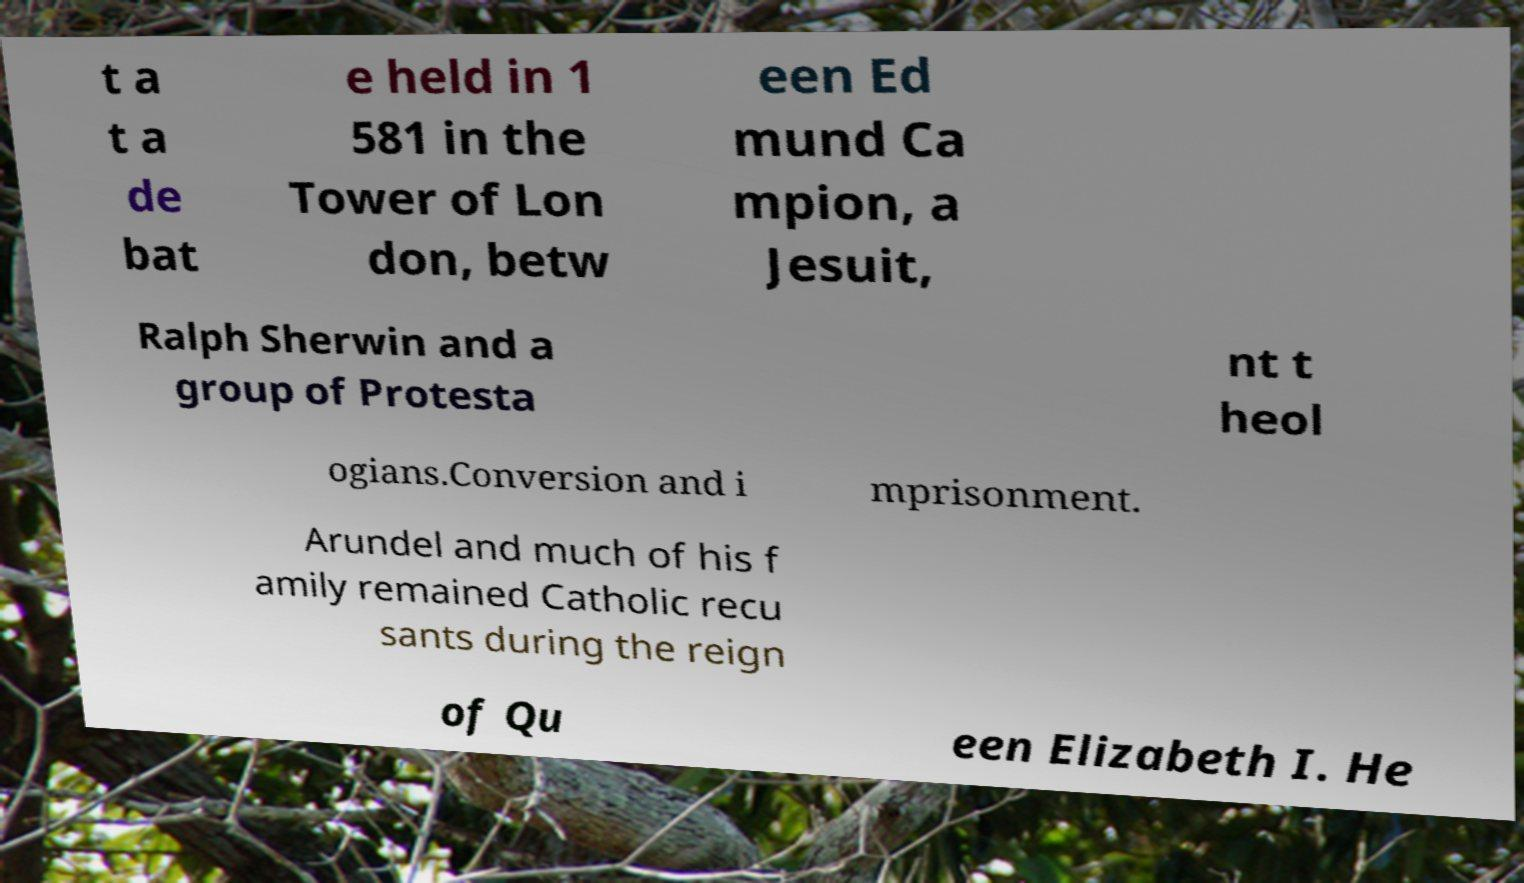There's text embedded in this image that I need extracted. Can you transcribe it verbatim? t a t a de bat e held in 1 581 in the Tower of Lon don, betw een Ed mund Ca mpion, a Jesuit, Ralph Sherwin and a group of Protesta nt t heol ogians.Conversion and i mprisonment. Arundel and much of his f amily remained Catholic recu sants during the reign of Qu een Elizabeth I. He 